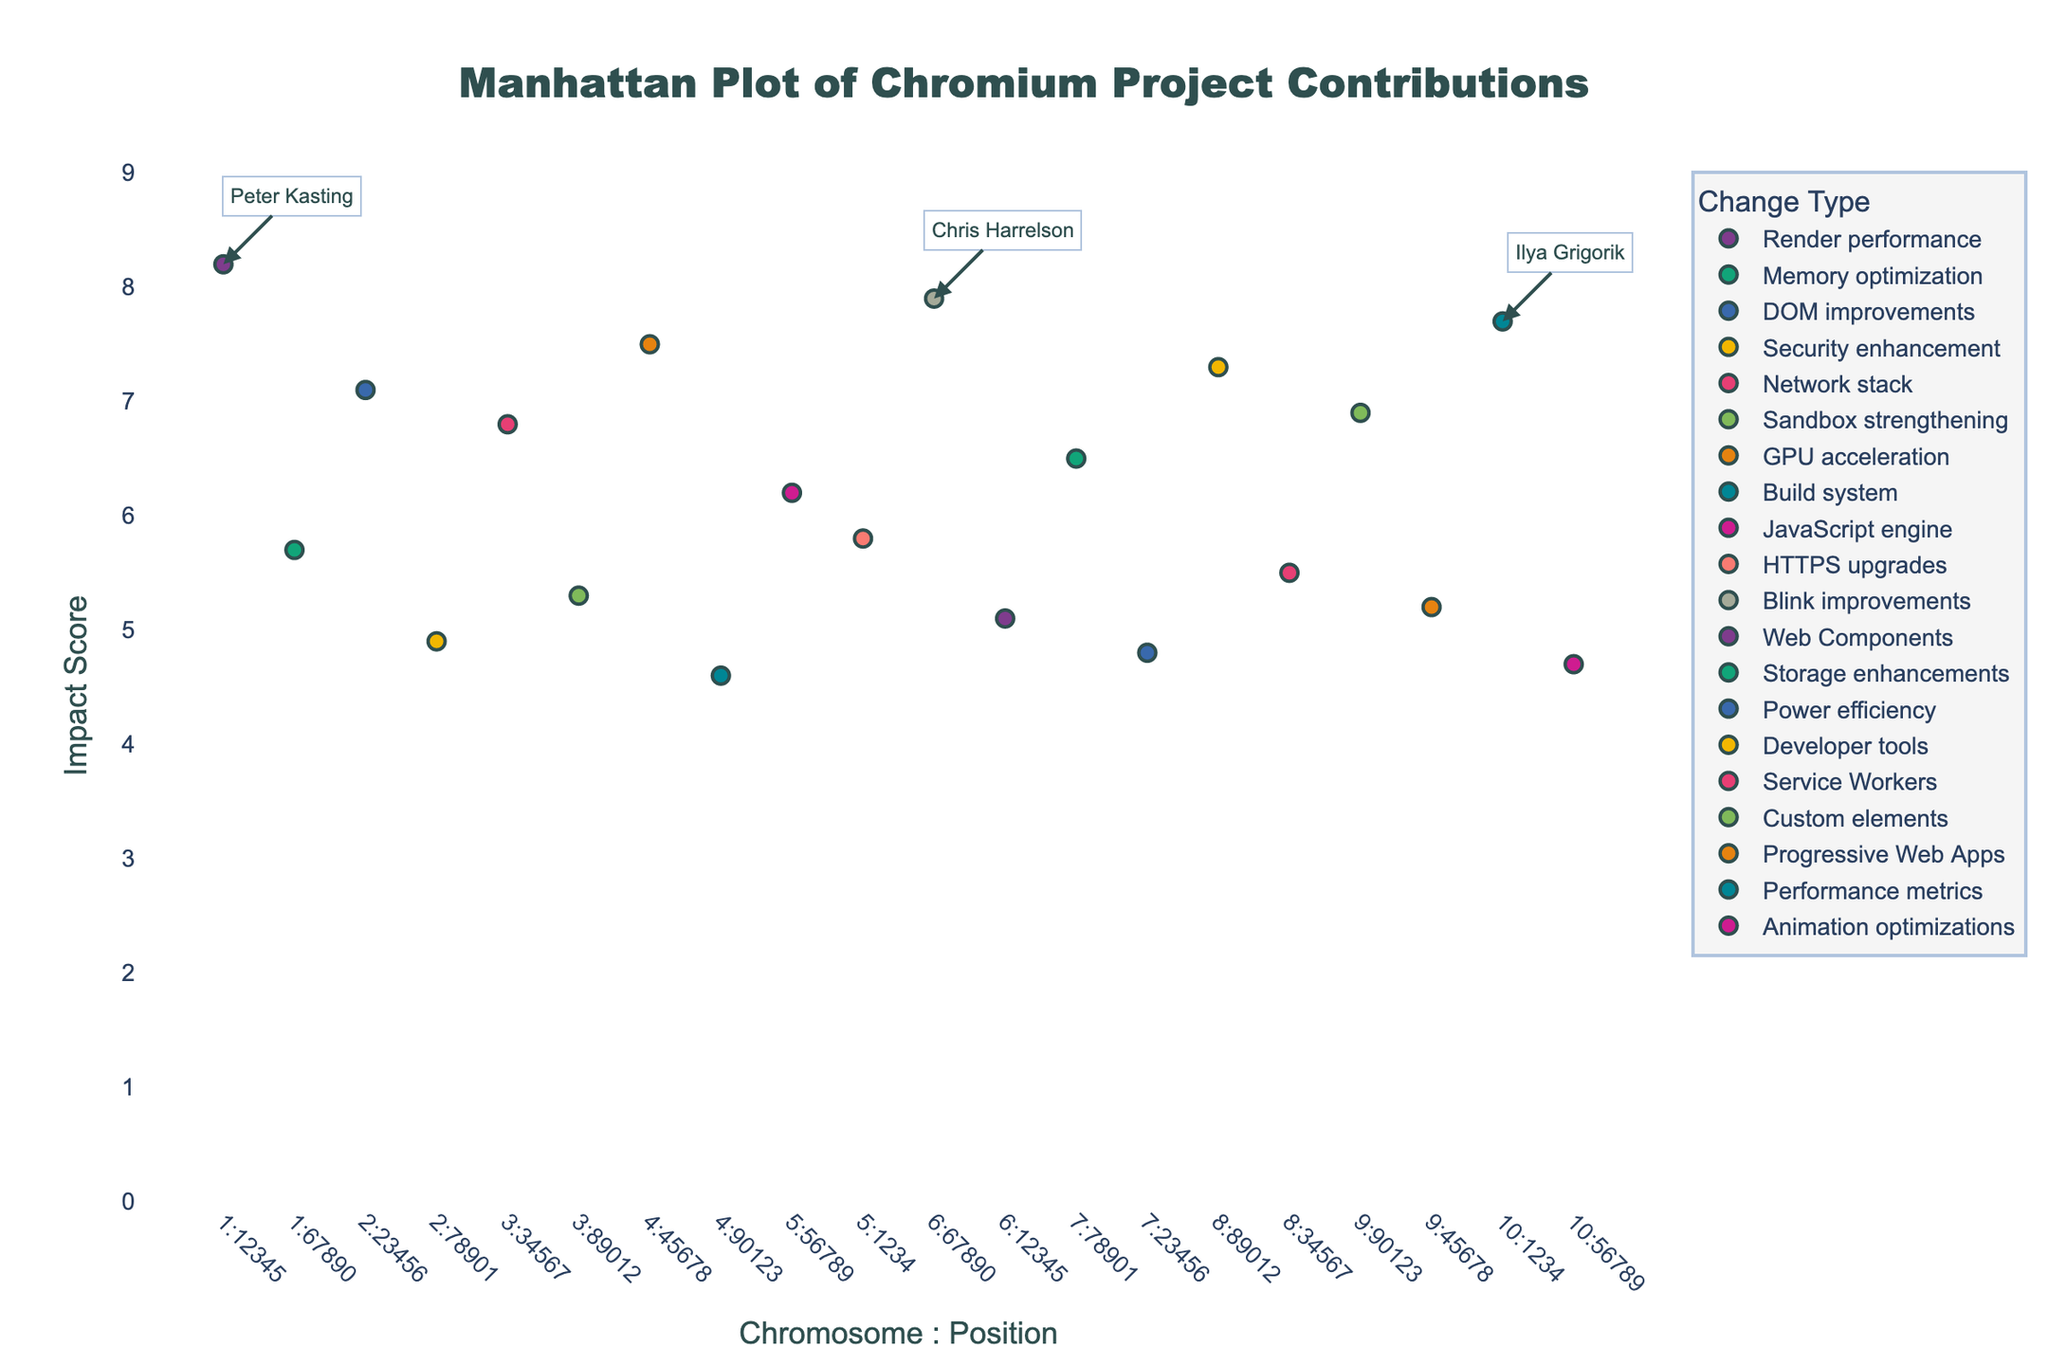What's the title of the plot? The title can be found at the top of the plot. It is usually clearly written in a larger font. The title here is "Manhattan Plot of Chromium Project Contributions".
Answer: Manhattan Plot of Chromium Project Contributions Which contributor has the highest impact score? To determine this, look for the highest point on the y-axis and check the annotation or the hover information. The highest point on the y-axis corresponds to an impact score of 8.2 by Peter Kasting.
Answer: Peter Kasting What are the axis labels of the plot? The labels can be found alongside the axes. The x-axis is labeled "Chromosome:Position" and the y-axis is labeled "Impact Score".
Answer: Chromosome:Position, Impact Score How many data points have an impact score above 7? Count the number of points that are above 7 on the y-axis. From the plot, there are 5 points above this threshold.
Answer: 5 What is the total impact score of contributions on chromosome 4? Identify the data points on chromosome 4 and sum their impact scores: 7.5 (Ken Russell) + 4.6 (Evan Martin) = 12.1.
Answer: 12.1 Compare the impact scores of contributions by Paul Irish and Ilya Grigorik. Who has a higher impact score? Locate the data points for Paul Irish and Ilya Grigorik. Paul Irish has an impact score of 7.3 and Ilya Grigorik has an impact score of 7.7. Ilya Grigorik has a higher impact score.
Answer: Ilya Grigorik Which change type has the highest average impact score? Calculate the average impact score for each change type. The average for "Render performance" is 8.2, "Memory optimization" is 5.7, etc. Compare these averages to find the highest one. "Performance metrics" has an average of 7.7, which is the highest.
Answer: Performance metrics How many contributions are there on chromosome 6? Count the number of data points on chromosome 6. According to the plot, there are 2 contributions: by Chris Harrelson and Alex Komoroske.
Answer: 2 Who has contributed to GPU acceleration, and what is their impact score? Find the data point labeled with "GPU acceleration". Ken Russell is the contributor with an impact score of 7.5.
Answer: Ken Russell, 7.5 